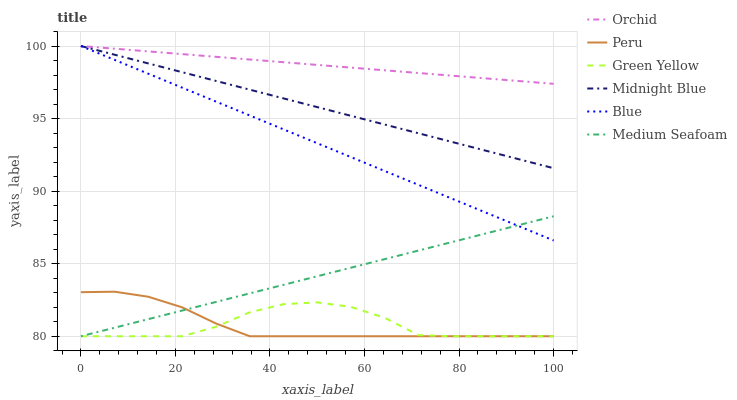Does Peru have the minimum area under the curve?
Answer yes or no. Yes. Does Orchid have the maximum area under the curve?
Answer yes or no. Yes. Does Midnight Blue have the minimum area under the curve?
Answer yes or no. No. Does Midnight Blue have the maximum area under the curve?
Answer yes or no. No. Is Medium Seafoam the smoothest?
Answer yes or no. Yes. Is Green Yellow the roughest?
Answer yes or no. Yes. Is Midnight Blue the smoothest?
Answer yes or no. No. Is Midnight Blue the roughest?
Answer yes or no. No. Does Midnight Blue have the lowest value?
Answer yes or no. No. Does Orchid have the highest value?
Answer yes or no. Yes. Does Peru have the highest value?
Answer yes or no. No. Is Peru less than Midnight Blue?
Answer yes or no. Yes. Is Blue greater than Peru?
Answer yes or no. Yes. Does Peru intersect Midnight Blue?
Answer yes or no. No. 